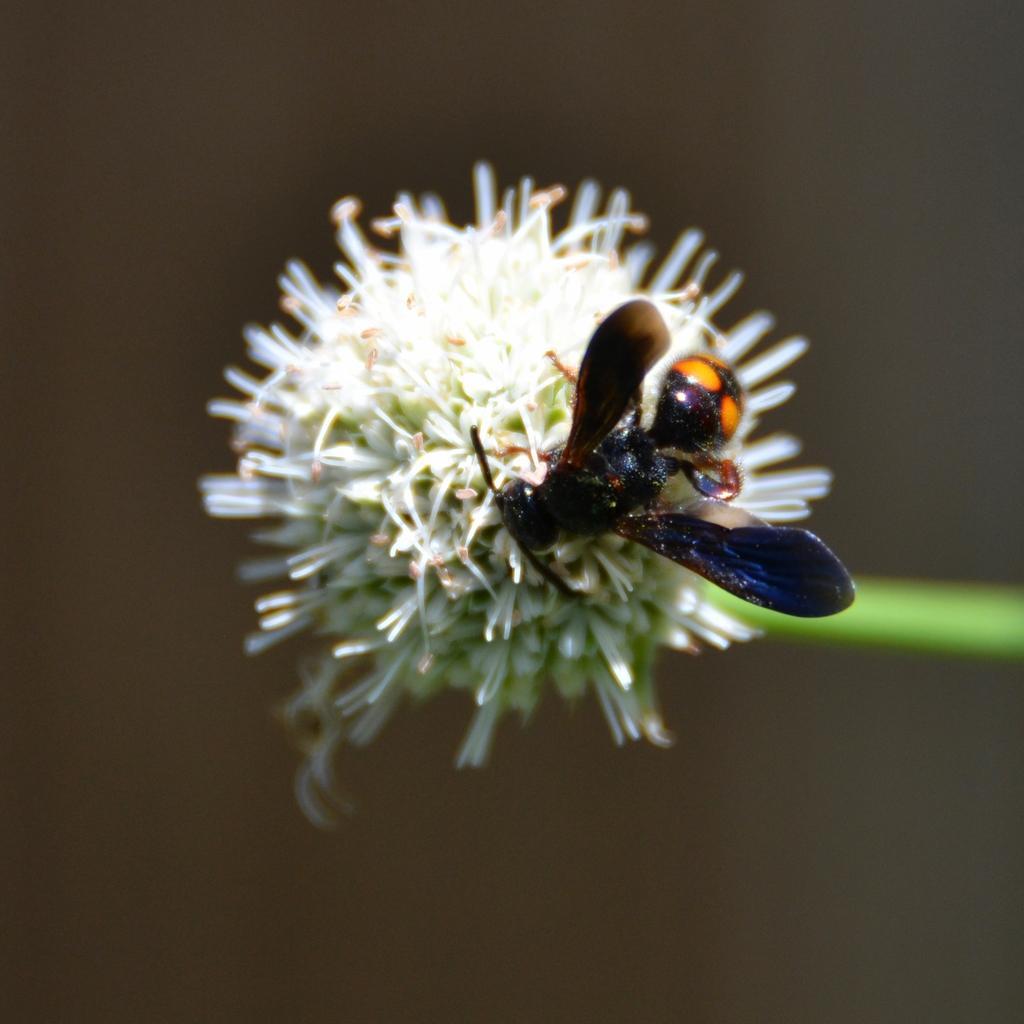Describe this image in one or two sentences. As we can see in the image there is an insect on flower and the background is blurred. 